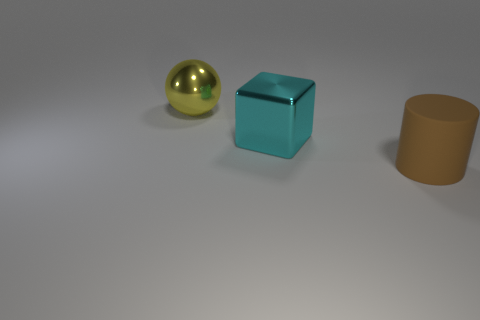Is the block made of the same material as the large cylinder?
Make the answer very short. No. There is a metal object in front of the large thing that is behind the cyan object; how many big cyan shiny objects are on the left side of it?
Offer a very short reply. 0. What color is the big metallic object in front of the big ball?
Offer a very short reply. Cyan. There is a metallic object behind the large metallic thing that is in front of the yellow metal sphere; what is its shape?
Keep it short and to the point. Sphere. Is the big ball the same color as the rubber cylinder?
Make the answer very short. No. How many cylinders are large brown rubber things or gray matte objects?
Offer a very short reply. 1. There is a object that is on the right side of the large metal sphere and on the left side of the rubber cylinder; what material is it?
Ensure brevity in your answer.  Metal. There is a matte cylinder; how many blocks are on the right side of it?
Make the answer very short. 0. Are the big object that is behind the big cyan thing and the object right of the big cyan block made of the same material?
Provide a succinct answer. No. What number of things are either objects behind the large brown object or big metallic objects?
Offer a terse response. 2. 